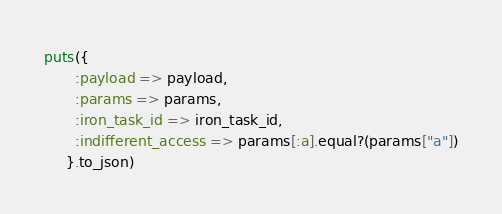Convert code to text. <code><loc_0><loc_0><loc_500><loc_500><_Ruby_>puts({
       :payload => payload,
       :params => params,
       :iron_task_id => iron_task_id,
       :indifferent_access => params[:a].equal?(params["a"])
     }.to_json)
</code> 